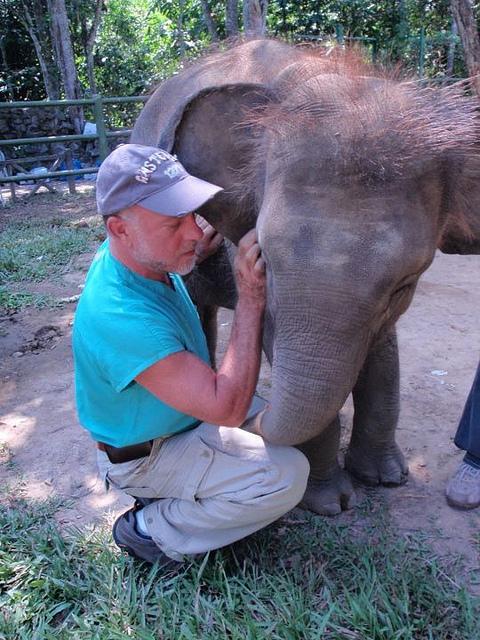Is this a house pet?
Give a very brief answer. No. What is the man doing?
Answer briefly. Checking elephant. Is this elephant likely a baby?
Short answer required. Yes. 